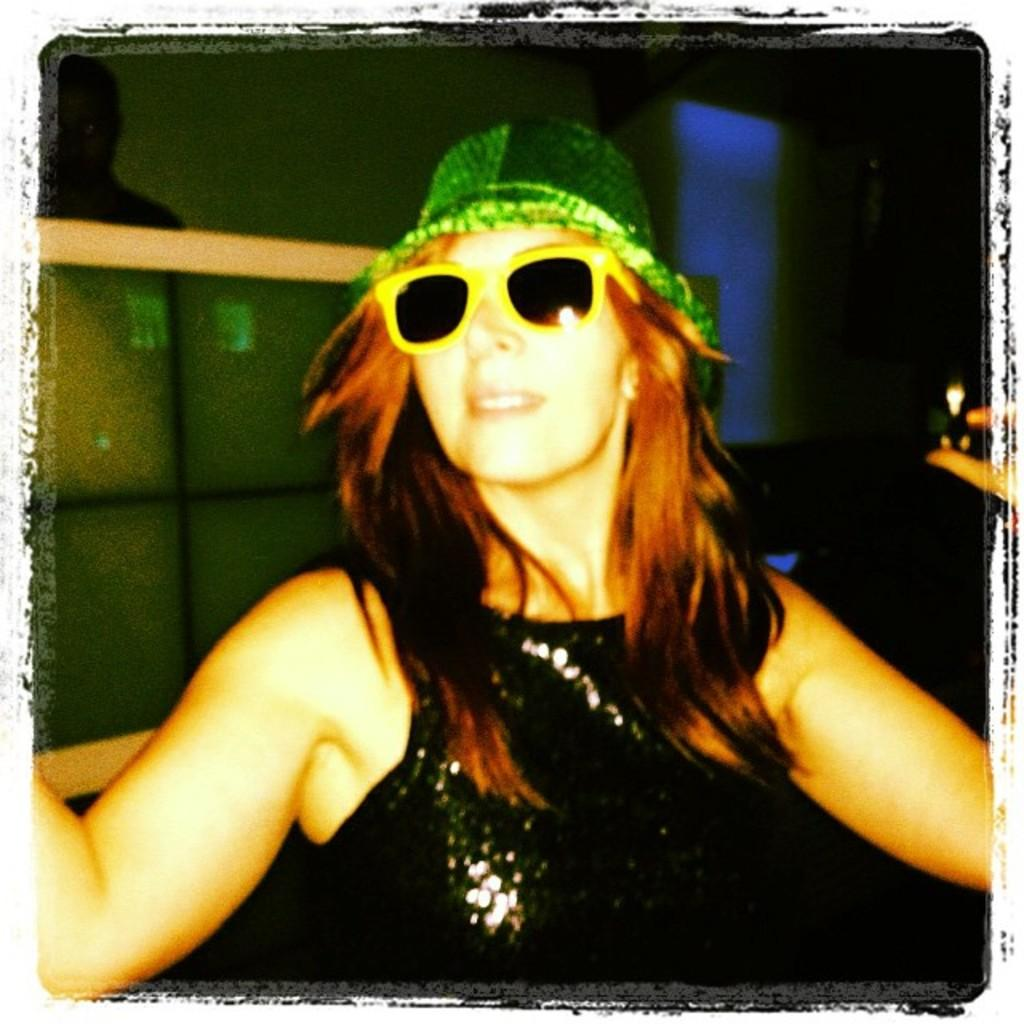What is the main subject in the front of the image? There is a person in the front of the image. What protective gear is the person wearing? The person is wearing goggles. What type of headwear is the person wearing? The person is wearing a hat. What is the person holding in the image? The person is holding an object. What can be observed about the background of the image? The background of the image is dark. Are there any other people visible in the image? Yes, there is at least one other person in the background of the image. What else can be seen in the background of the image? There are objects visible in the background of the image. What type of crime is being committed by the person in the image? There is no indication of any crime being committed in the image. What amusement park ride is the person using in the image? There is no amusement park ride present in the image. 